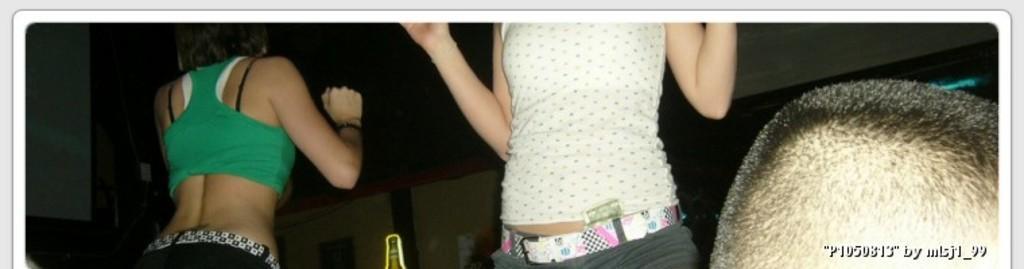How would you summarize this image in a sentence or two? In this image there are three persons, in the bottom right there is text. 